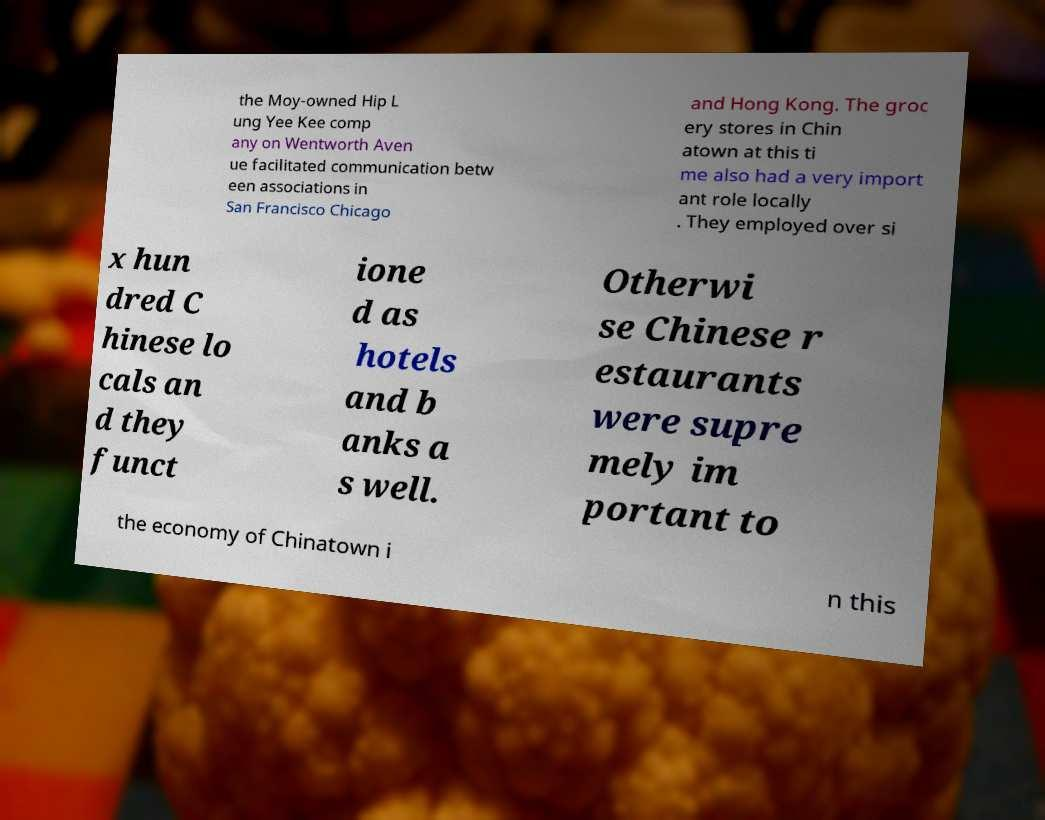Please read and relay the text visible in this image. What does it say? the Moy-owned Hip L ung Yee Kee comp any on Wentworth Aven ue facilitated communication betw een associations in San Francisco Chicago and Hong Kong. The groc ery stores in Chin atown at this ti me also had a very import ant role locally . They employed over si x hun dred C hinese lo cals an d they funct ione d as hotels and b anks a s well. Otherwi se Chinese r estaurants were supre mely im portant to the economy of Chinatown i n this 